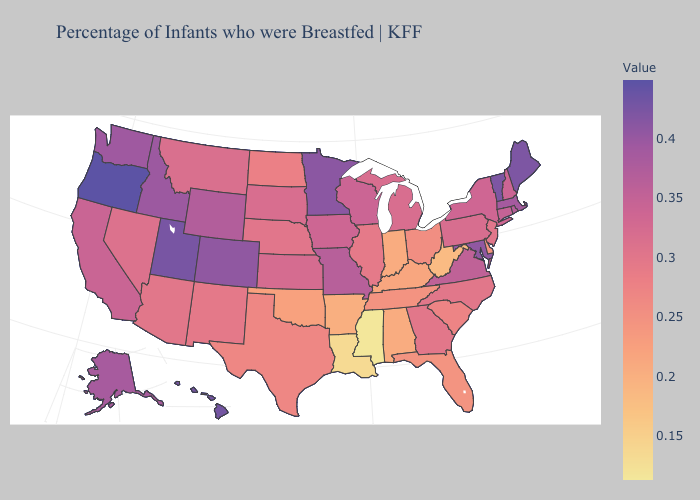Is the legend a continuous bar?
Concise answer only. Yes. Does Rhode Island have the lowest value in the Northeast?
Short answer required. No. Is the legend a continuous bar?
Concise answer only. Yes. Among the states that border Alabama , which have the lowest value?
Concise answer only. Mississippi. Does Idaho have a higher value than Oregon?
Concise answer only. No. 